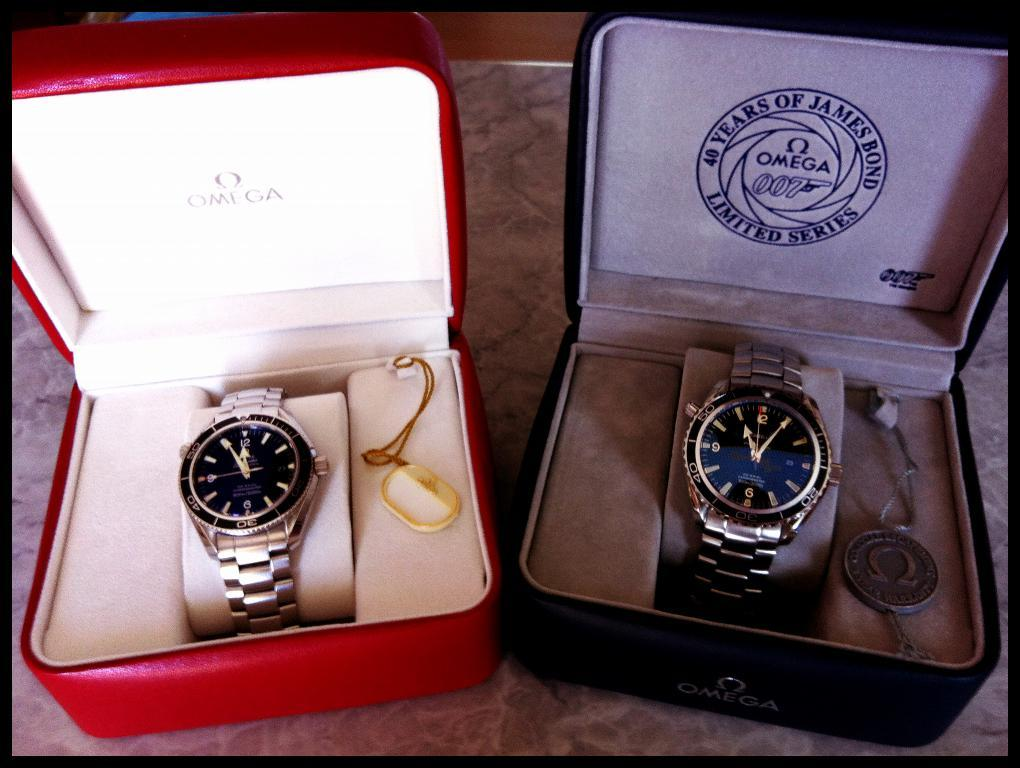<image>
Relay a brief, clear account of the picture shown. Two Omega watches, one is a limited edition of a 007 James Bond watch. 